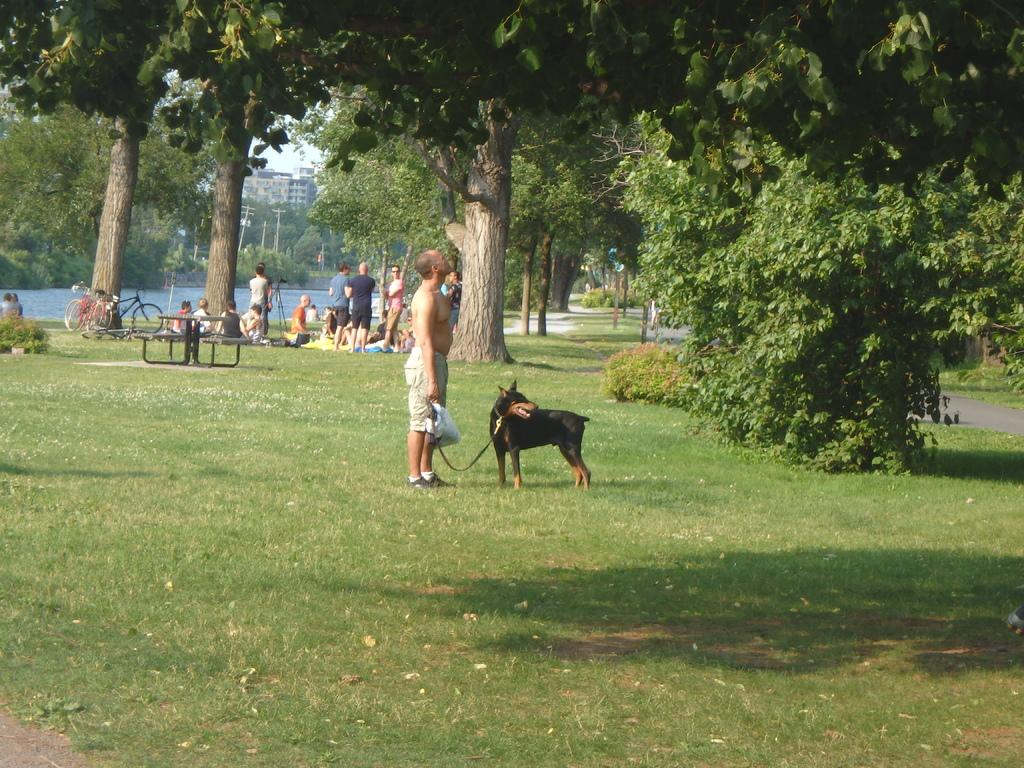What are the people in the image standing on? The people in the image are standing on the grass. What type of vegetation is present in the area? There is grass in the area. What can be seen in the background of the image? There are trees around the area. How many people have died in the image? There is no indication of death or any deceased individuals in the image. 